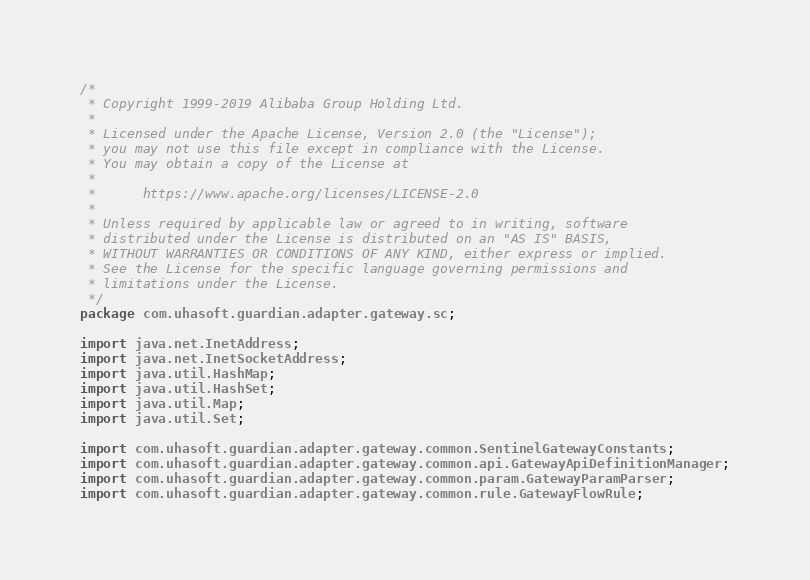Convert code to text. <code><loc_0><loc_0><loc_500><loc_500><_Java_>/*
 * Copyright 1999-2019 Alibaba Group Holding Ltd.
 *
 * Licensed under the Apache License, Version 2.0 (the "License");
 * you may not use this file except in compliance with the License.
 * You may obtain a copy of the License at
 *
 *      https://www.apache.org/licenses/LICENSE-2.0
 *
 * Unless required by applicable law or agreed to in writing, software
 * distributed under the License is distributed on an "AS IS" BASIS,
 * WITHOUT WARRANTIES OR CONDITIONS OF ANY KIND, either express or implied.
 * See the License for the specific language governing permissions and
 * limitations under the License.
 */
package com.uhasoft.guardian.adapter.gateway.sc;

import java.net.InetAddress;
import java.net.InetSocketAddress;
import java.util.HashMap;
import java.util.HashSet;
import java.util.Map;
import java.util.Set;

import com.uhasoft.guardian.adapter.gateway.common.SentinelGatewayConstants;
import com.uhasoft.guardian.adapter.gateway.common.api.GatewayApiDefinitionManager;
import com.uhasoft.guardian.adapter.gateway.common.param.GatewayParamParser;
import com.uhasoft.guardian.adapter.gateway.common.rule.GatewayFlowRule;</code> 